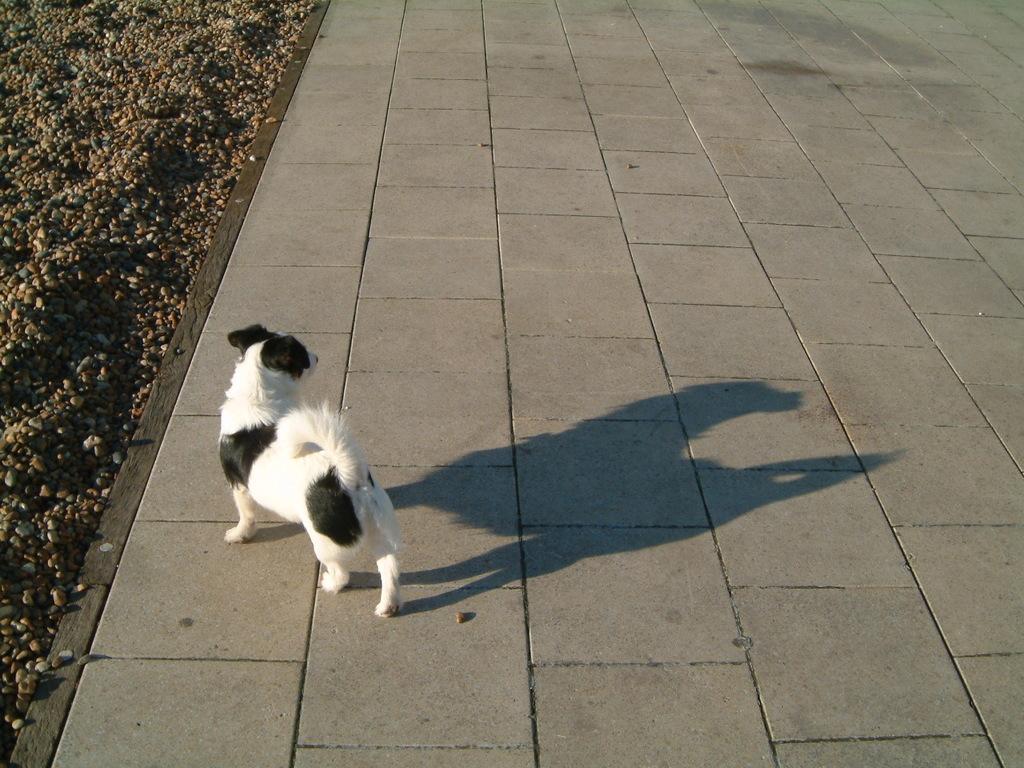Can you describe this image briefly? In this image, we can see we can see white dog is walking on the walkway. Left side of the image, we can see stones. 